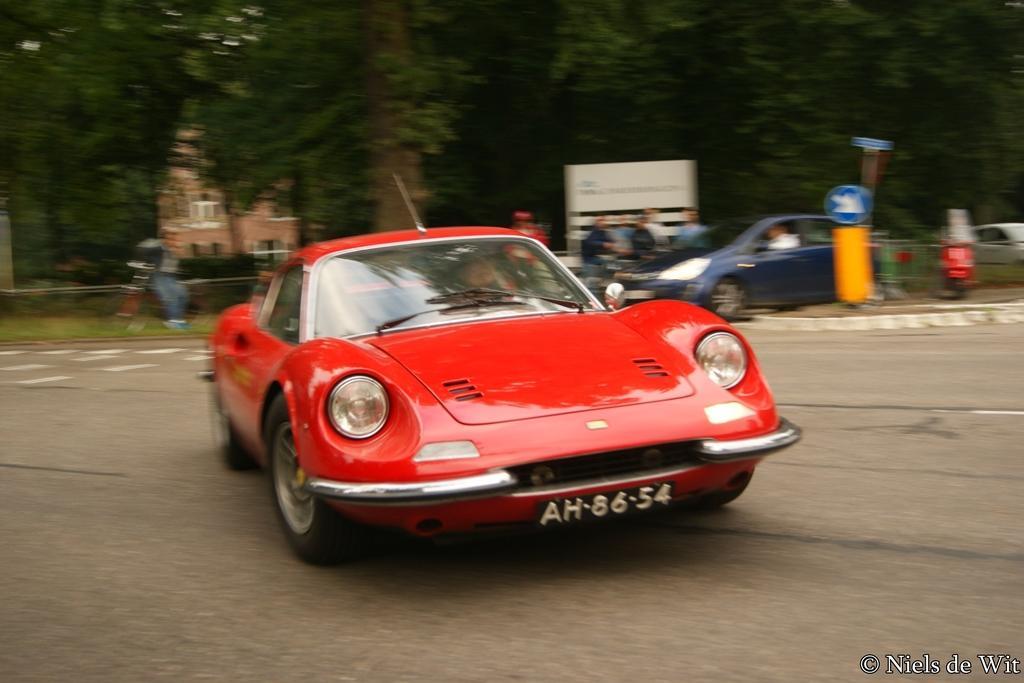Can you describe this image briefly? This picture is clicked outside. In the center we can see the two cars seems to be running on the ground and there are some objects on the ground. The background of the image is blurry and we can see the group of persons, houses and the trees. In the bottom right corner there is a text on the image. 